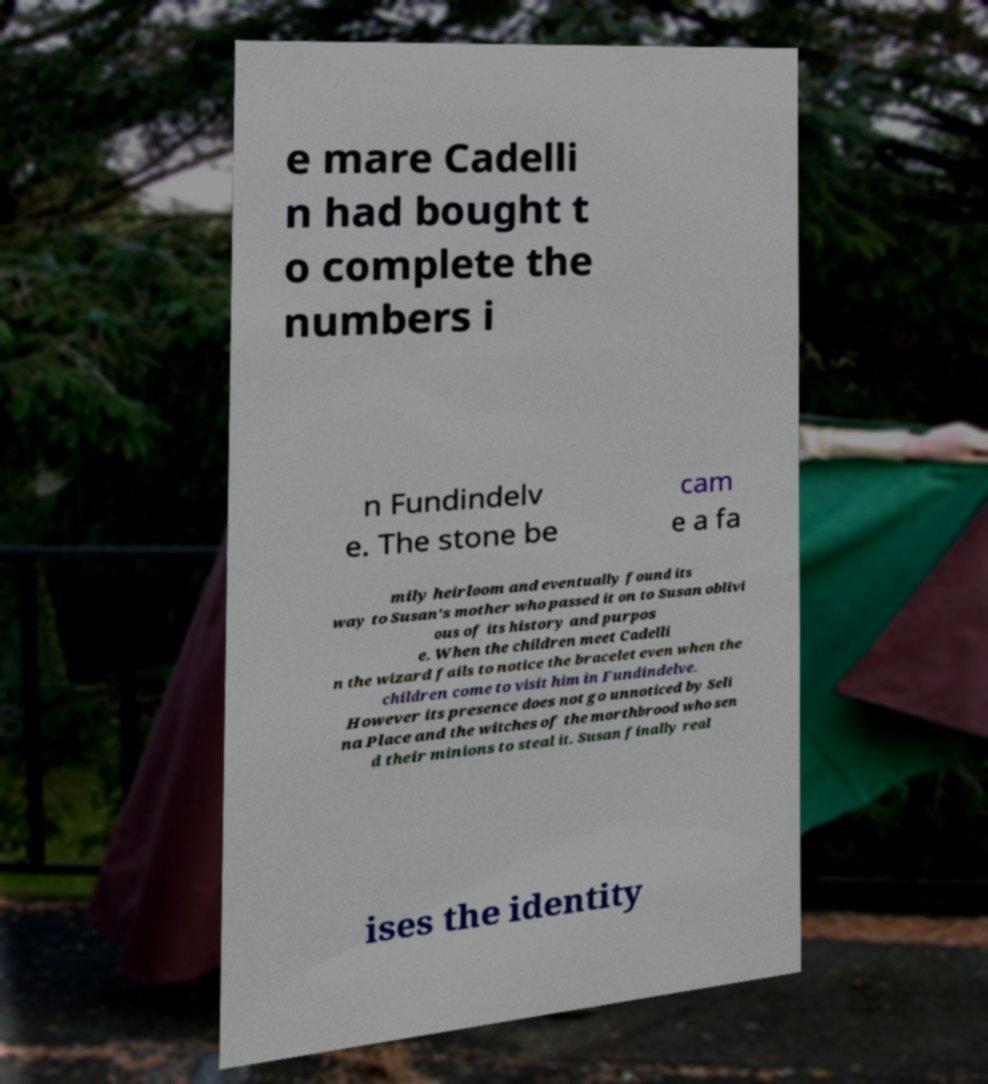Can you accurately transcribe the text from the provided image for me? e mare Cadelli n had bought t o complete the numbers i n Fundindelv e. The stone be cam e a fa mily heirloom and eventually found its way to Susan's mother who passed it on to Susan oblivi ous of its history and purpos e. When the children meet Cadelli n the wizard fails to notice the bracelet even when the children come to visit him in Fundindelve. However its presence does not go unnoticed by Seli na Place and the witches of the morthbrood who sen d their minions to steal it. Susan finally real ises the identity 